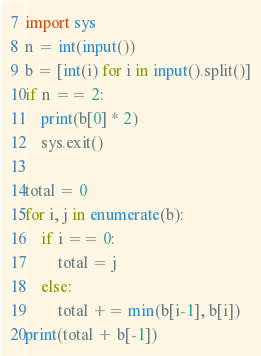Convert code to text. <code><loc_0><loc_0><loc_500><loc_500><_Python_>import sys
n = int(input())
b = [int(i) for i in input().split()]
if n == 2:
    print(b[0] * 2)
    sys.exit()

total = 0
for i, j in enumerate(b):
    if i == 0:
        total = j
    else:
        total += min(b[i-1], b[i])
print(total + b[-1])</code> 